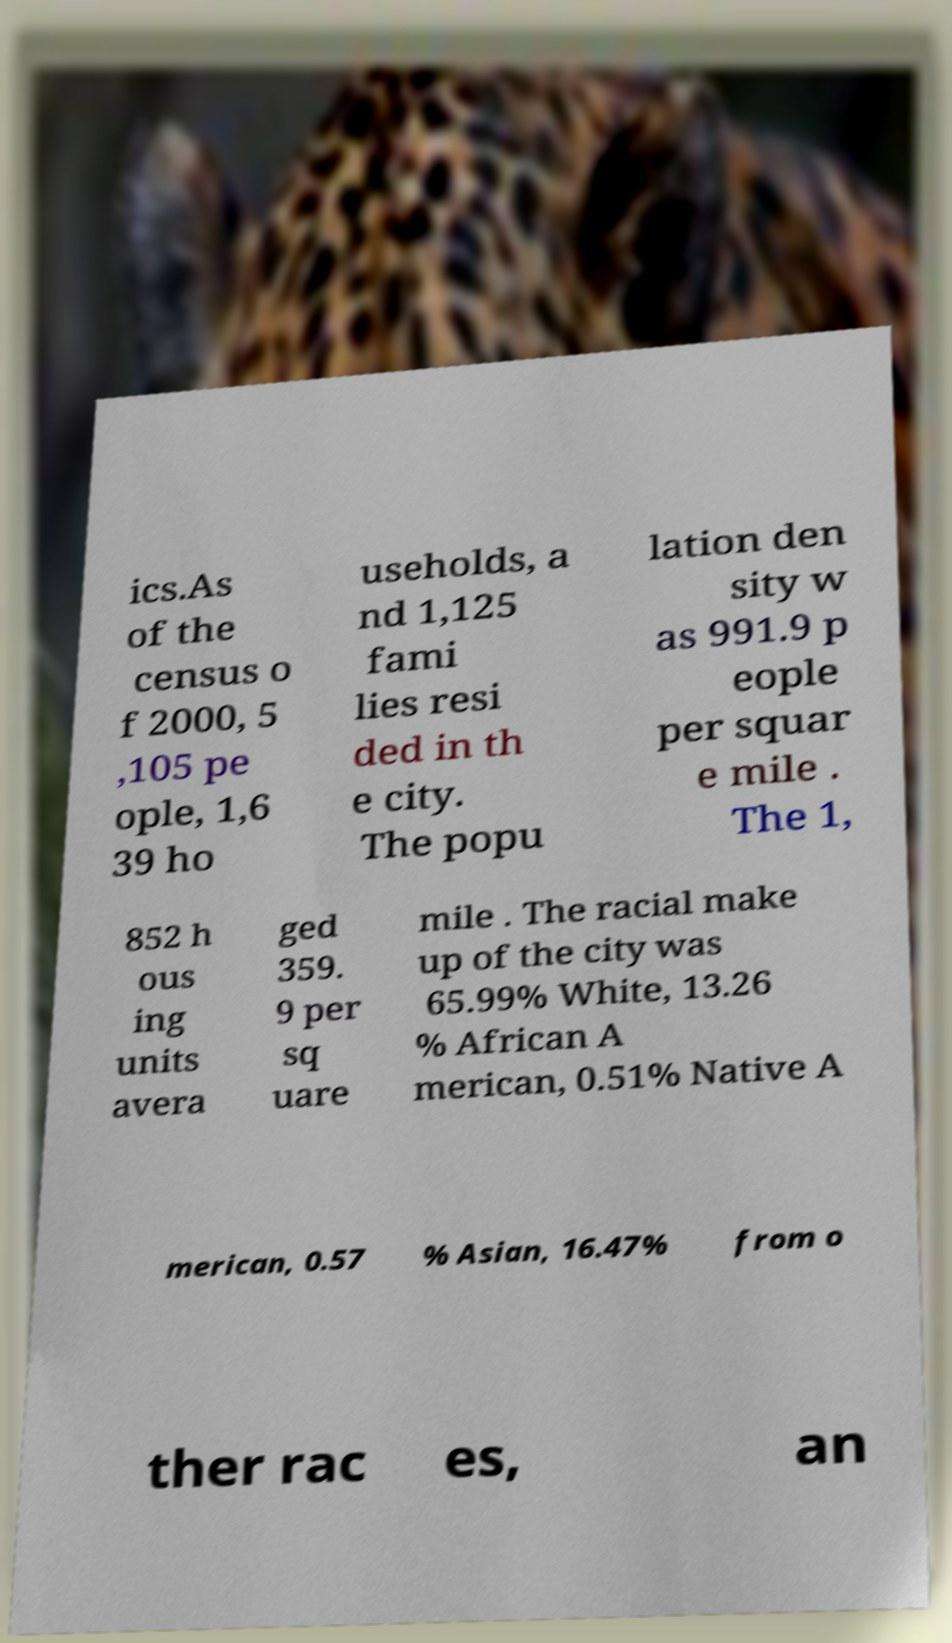Could you extract and type out the text from this image? ics.As of the census o f 2000, 5 ,105 pe ople, 1,6 39 ho useholds, a nd 1,125 fami lies resi ded in th e city. The popu lation den sity w as 991.9 p eople per squar e mile . The 1, 852 h ous ing units avera ged 359. 9 per sq uare mile . The racial make up of the city was 65.99% White, 13.26 % African A merican, 0.51% Native A merican, 0.57 % Asian, 16.47% from o ther rac es, an 